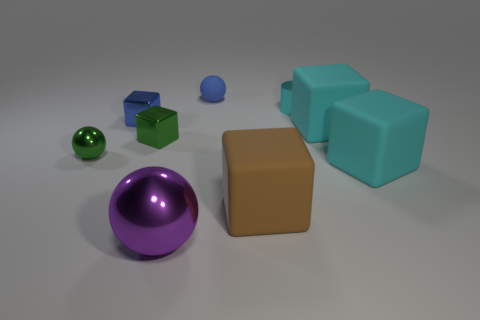Is the material of the tiny sphere behind the cylinder the same as the large brown block?
Make the answer very short. Yes. Are there the same number of big blocks behind the small metallic cylinder and purple metallic spheres left of the blue shiny block?
Provide a succinct answer. Yes. There is a tiny thing that is the same color as the small rubber ball; what is its material?
Give a very brief answer. Metal. How many big objects are behind the large rubber cube to the left of the cylinder?
Your answer should be very brief. 2. There is a metal object that is on the right side of the purple thing; is it the same color as the large cube that is behind the green ball?
Offer a very short reply. Yes. There is a green block that is the same size as the cyan cylinder; what material is it?
Give a very brief answer. Metal. There is a metallic object that is in front of the metallic sphere to the left of the sphere in front of the large brown object; what shape is it?
Give a very brief answer. Sphere. There is a matte thing that is the same size as the green shiny sphere; what shape is it?
Offer a terse response. Sphere. What number of big metallic balls are to the left of the small green metallic object left of the small blue object that is in front of the blue matte object?
Keep it short and to the point. 0. Is the number of small green things that are behind the green metallic sphere greater than the number of green metal cubes on the right side of the big brown matte object?
Offer a terse response. Yes. 